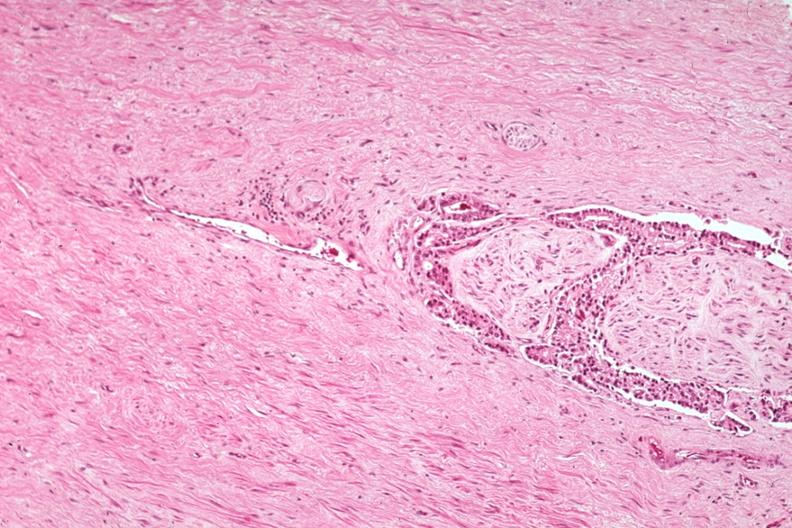does this image show med excellent example of perineural invasion?
Answer the question using a single word or phrase. Yes 